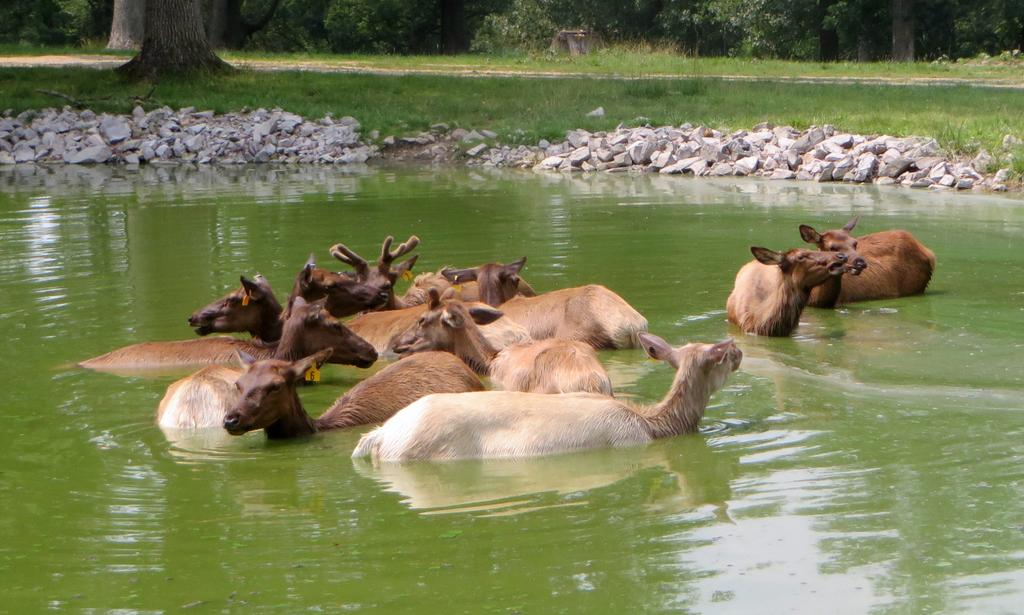What type of animals can be seen in the water in the image? There are animals in the water in the image. What other elements can be seen in the image besides the animals? There are rocks visible in the image, as well as grass. What type of vegetation is present at the top of the image? There are trees at the top of the image. What type of vegetable is being used to tell a story in the image? There is no vegetable present in the image, nor is there any indication of a story being told. 